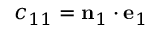<formula> <loc_0><loc_0><loc_500><loc_500>c _ { 1 1 } = n _ { 1 } \cdot e _ { 1 }</formula> 